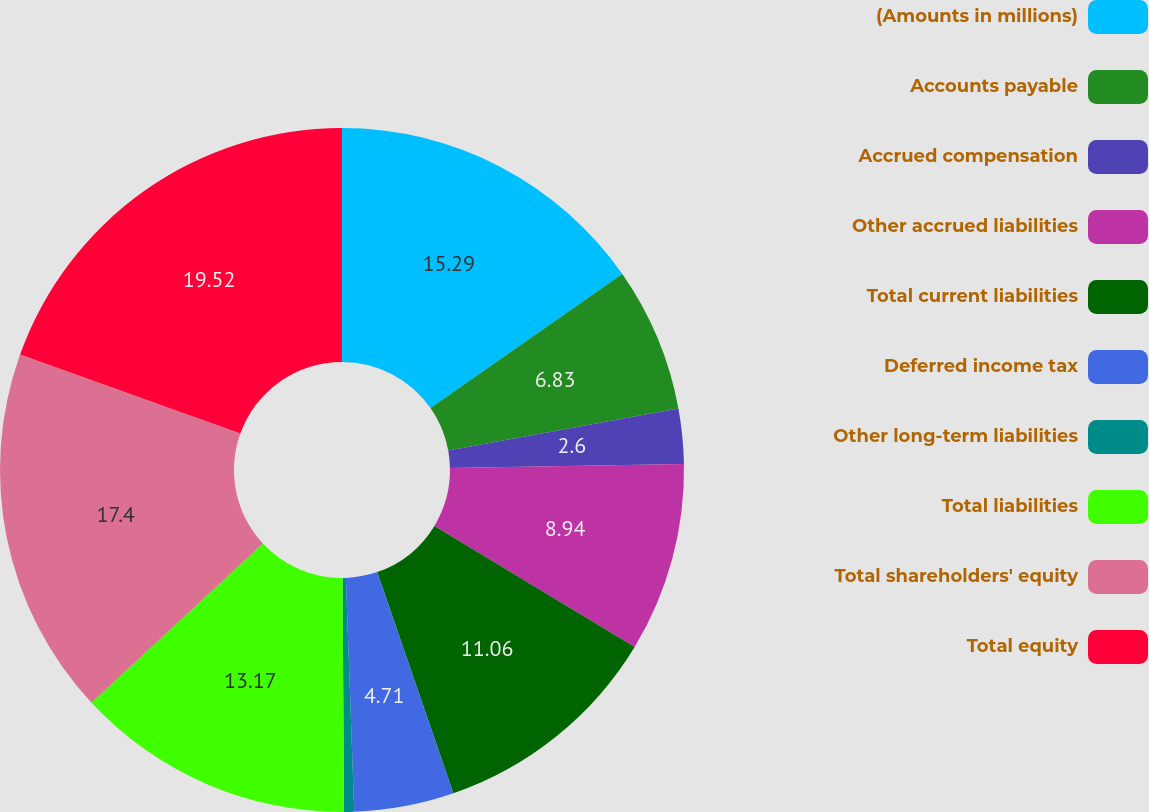<chart> <loc_0><loc_0><loc_500><loc_500><pie_chart><fcel>(Amounts in millions)<fcel>Accounts payable<fcel>Accrued compensation<fcel>Other accrued liabilities<fcel>Total current liabilities<fcel>Deferred income tax<fcel>Other long-term liabilities<fcel>Total liabilities<fcel>Total shareholders' equity<fcel>Total equity<nl><fcel>15.29%<fcel>6.83%<fcel>2.6%<fcel>8.94%<fcel>11.06%<fcel>4.71%<fcel>0.48%<fcel>13.17%<fcel>17.4%<fcel>19.52%<nl></chart> 